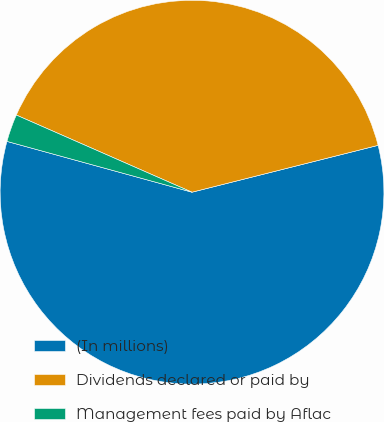Convert chart to OTSL. <chart><loc_0><loc_0><loc_500><loc_500><pie_chart><fcel>(In millions)<fcel>Dividends declared or paid by<fcel>Management fees paid by Aflac<nl><fcel>58.19%<fcel>39.49%<fcel>2.32%<nl></chart> 